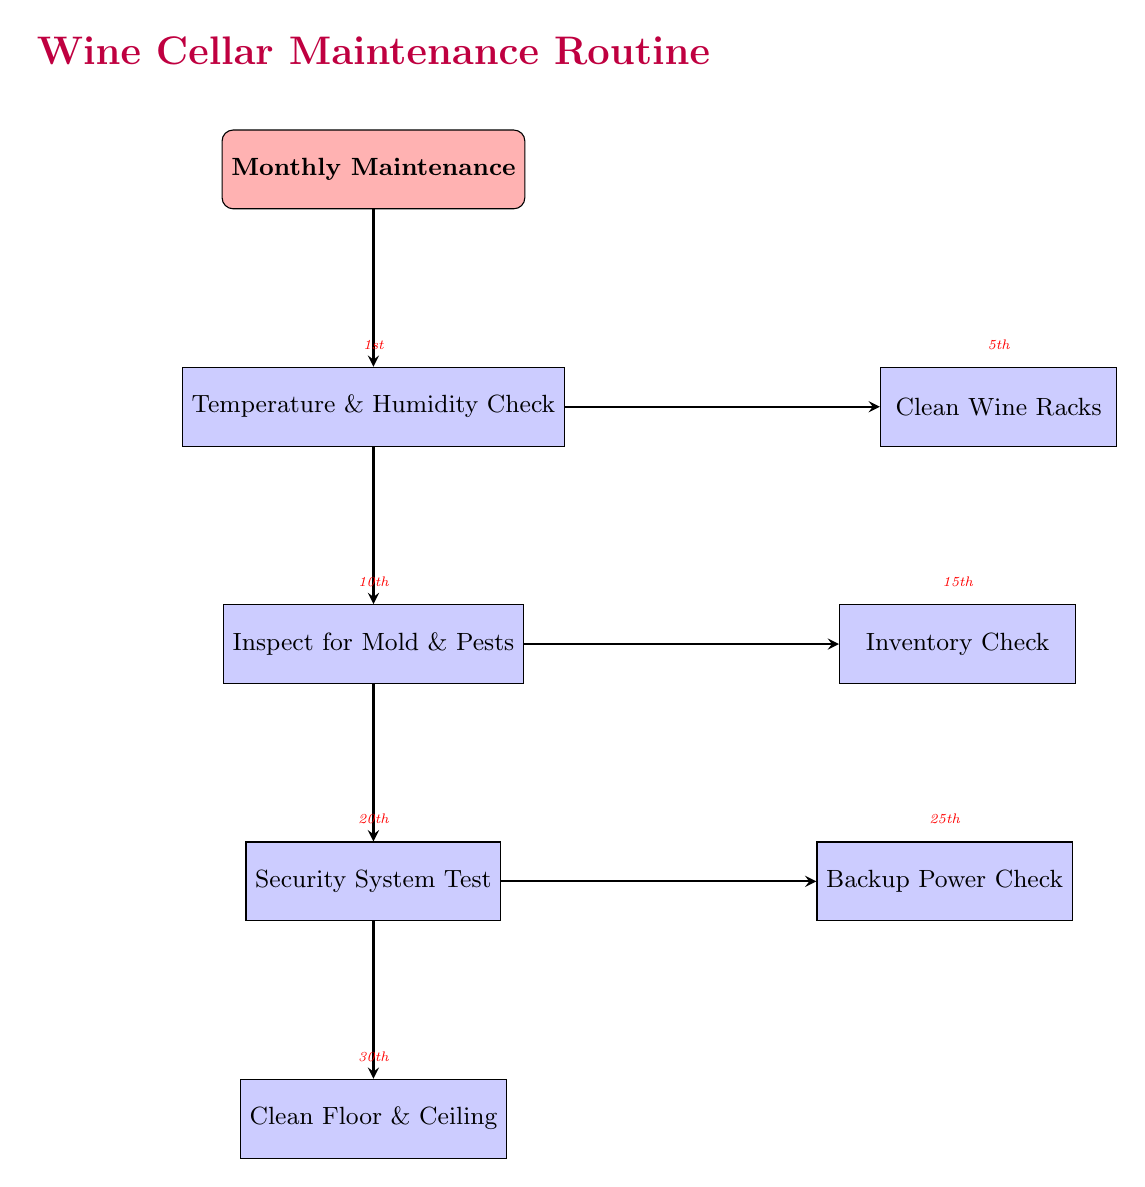What task is scheduled for the 10th of the month? According to the timeline labels in the diagram, the task listed under the 10th is "Inspect for Mold & Pests."
Answer: Inspect for Mold & Pests How many nodes are present in the diagram? The diagram contains seven nodes, which are "Monthly Maintenance," "Temperature & Humidity Check," "Clean Wine Racks," "Inspect for Mold & Pests," "Inventory Check," "Security System Test," "Backup Power Check," and "Clean Floor & Ceiling."
Answer: Seven What is the first task in the maintenance routine? The first task listed is "Temperature & Humidity Check" as seen in the diagram sequence.
Answer: Temperature & Humidity Check Which task follows the "Security System Test"? Following the "Security System Test," the next task shown in the diagram is "Backup Power Check."
Answer: Backup Power Check What are the two entities associated with "Clean Wine Racks"? The diagram specifies "Microfiber Cloth" and "Eco-Friendly Wood Cleaner" as the entities used for the task "Clean Wine Racks."
Answer: Microfiber Cloth, Eco-Friendly Wood Cleaner What is the timeline for the "Inventory Check" task? The timeline beside "Inventory Check" indicates that this task is scheduled for the 15th of the month.
Answer: 15th Which entities are listed for the "Temperature & Humidity Check"? The entities associated with "Temperature & Humidity Check" include "ThermoPro Humidity Monitor" and "Digital Hygrometer" as noted in the diagram.
Answer: ThermoPro Humidity Monitor, Digital Hygrometer Which tasks occur before the "Clean Floor & Ceiling"? The tasks that occur before "Clean Floor & Ceiling" are "Temperature & Humidity Check," "Clean Wine Racks," "Inspect for Mold & Pests," "Inventory Check," "Security System Test," and "Backup Power Check." All are in sequential order leading to "Clean Floor & Ceiling."
Answer: Temperature & Humidity Check, Clean Wine Racks, Inspect for Mold & Pests, Inventory Check, Security System Test, Backup Power Check 